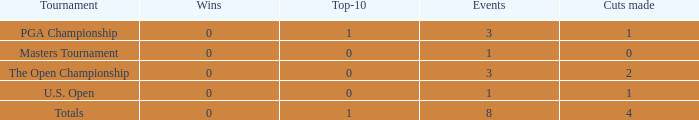Could you parse the entire table as a dict? {'header': ['Tournament', 'Wins', 'Top-10', 'Events', 'Cuts made'], 'rows': [['PGA Championship', '0', '1', '3', '1'], ['Masters Tournament', '0', '0', '1', '0'], ['The Open Championship', '0', '0', '3', '2'], ['U.S. Open', '0', '0', '1', '1'], ['Totals', '0', '1', '8', '4']]} For majors with 8 events played and more than 1 made cut, what is the most top-10s recorded? 1.0. 